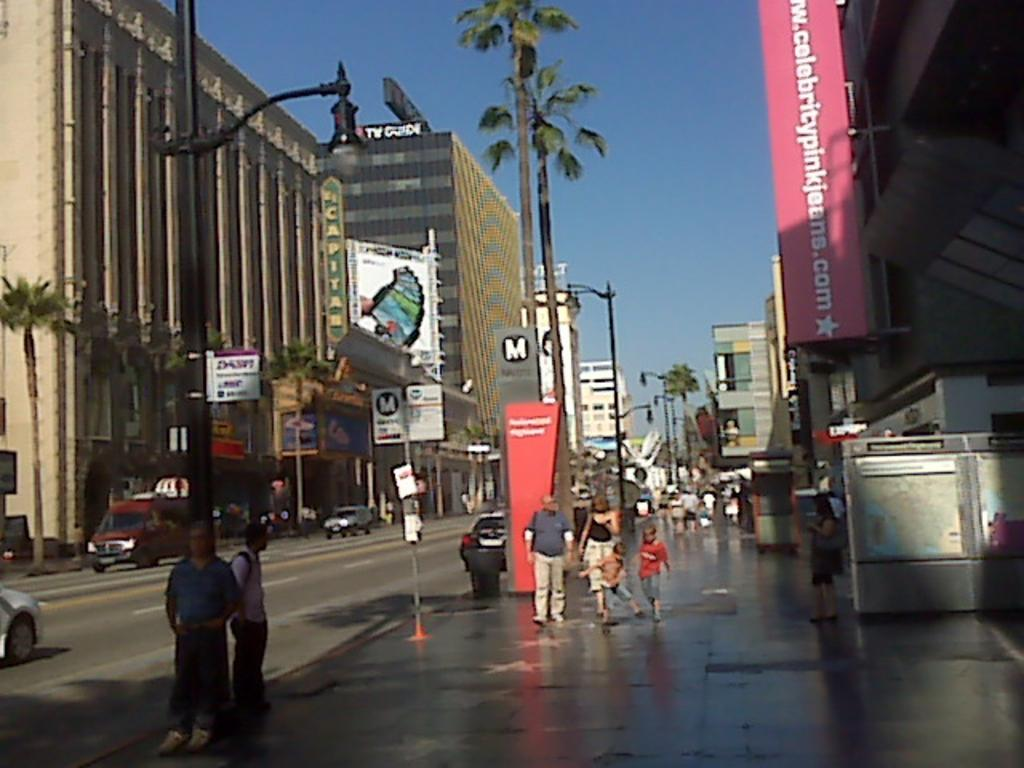<image>
Summarize the visual content of the image. An outside sidewalk with people on the street and a sign that says www.celebritypinkjeans.com 